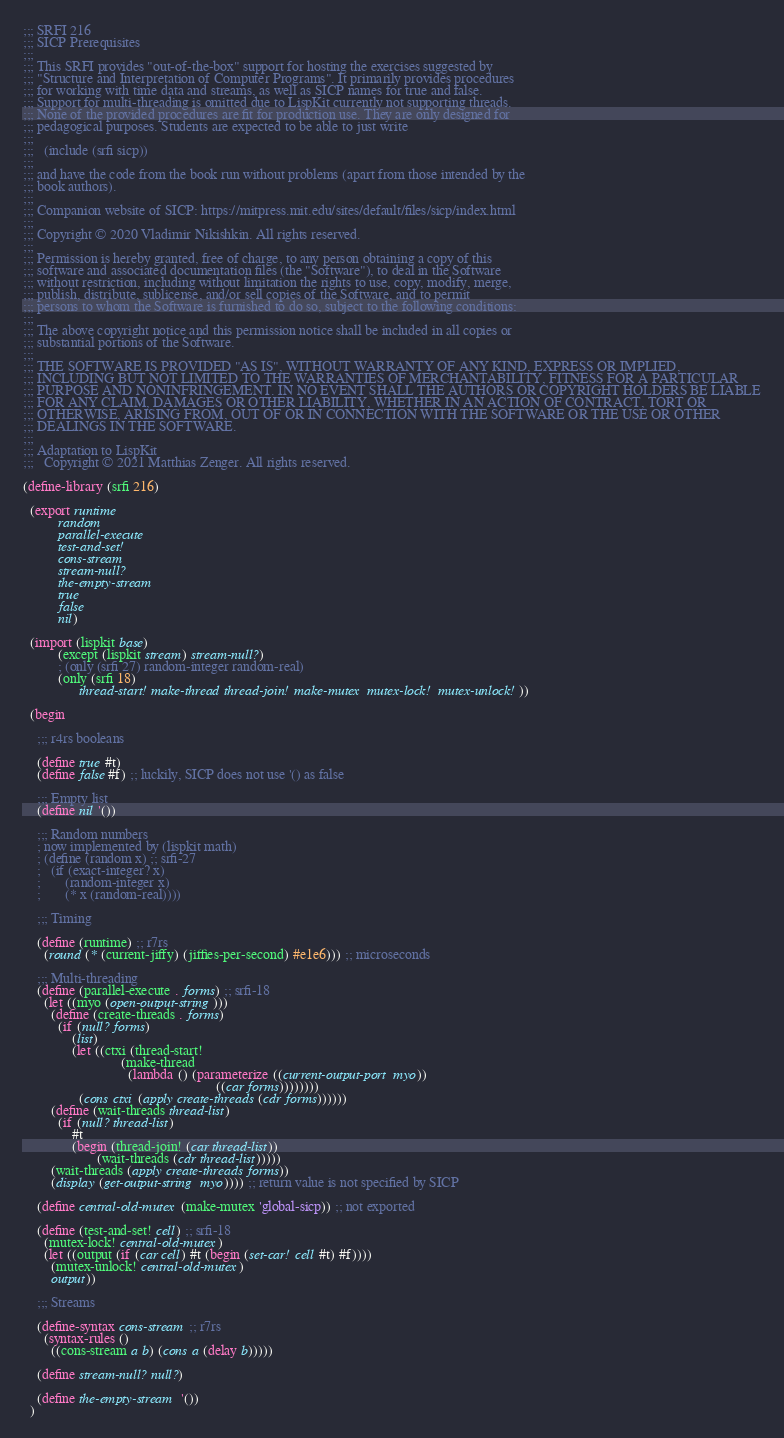Convert code to text. <code><loc_0><loc_0><loc_500><loc_500><_Scheme_>;;; SRFI 216
;;; SICP Prerequisites
;;;
;;; This SRFI provides "out-of-the-box" support for hosting the exercises suggested by
;;; "Structure and Interpretation of Computer Programs". It primarily provides procedures
;;; for working with time data and streams, as well as SICP names for true and false.
;;; Support for multi-threading is omitted due to LispKit currently not supporting threads.
;;; None of the provided procedures are fit for production use. They are only designed for
;;; pedagogical purposes. Students are expected to be able to just write
;;;
;;;   (include (srfi sicp))
;;;
;;; and have the code from the book run without problems (apart from those intended by the
;;; book authors).
;;;
;;; Companion website of SICP: https://mitpress.mit.edu/sites/default/files/sicp/index.html
;;;
;;; Copyright © 2020 Vladimir Nikishkin. All rights reserved.
;;;
;;; Permission is hereby granted, free of charge, to any person obtaining a copy of this
;;; software and associated documentation files (the "Software"), to deal in the Software
;;; without restriction, including without limitation the rights to use, copy, modify, merge,
;;; publish, distribute, sublicense, and/or sell copies of the Software, and to permit
;;; persons to whom the Software is furnished to do so, subject to the following conditions:
;;;
;;; The above copyright notice and this permission notice shall be included in all copies or
;;; substantial portions of the Software.
;;;
;;; THE SOFTWARE IS PROVIDED "AS IS", WITHOUT WARRANTY OF ANY KIND, EXPRESS OR IMPLIED,
;;; INCLUDING BUT NOT LIMITED TO THE WARRANTIES OF MERCHANTABILITY, FITNESS FOR A PARTICULAR
;;; PURPOSE AND NONINFRINGEMENT. IN NO EVENT SHALL THE AUTHORS OR COPYRIGHT HOLDERS BE LIABLE
;;; FOR ANY CLAIM, DAMAGES OR OTHER LIABILITY, WHETHER IN AN ACTION OF CONTRACT, TORT OR
;;; OTHERWISE, ARISING FROM, OUT OF OR IN CONNECTION WITH THE SOFTWARE OR THE USE OR OTHER
;;; DEALINGS IN THE SOFTWARE.
;;;
;;; Adaptation to LispKit
;;;   Copyright © 2021 Matthias Zenger. All rights reserved.

(define-library (srfi 216)

  (export runtime
          random
          parallel-execute
          test-and-set!
          cons-stream
          stream-null?
          the-empty-stream
          true
          false
          nil)

  (import (lispkit base)
          (except (lispkit stream) stream-null?)
          ; (only (srfi 27) random-integer random-real)
          (only (srfi 18)
                thread-start! make-thread thread-join! make-mutex mutex-lock! mutex-unlock!))

  (begin

    ;;; r4rs booleans

    (define true #t)
    (define false #f) ;; luckily, SICP does not use '() as false

    ;;; Empty list
    (define nil '())

    ;;; Random numbers
    ; now implemented by (lispkit math)
    ; (define (random x) ;; srfi-27
    ;   (if (exact-integer? x)
    ;       (random-integer x)
    ;       (* x (random-real))))

    ;;; Timing

    (define (runtime) ;; r7rs
      (round (* (current-jiffy) (jiffies-per-second) #e1e6))) ;; microseconds

    ;;; Multi-threading
    (define (parallel-execute . forms) ;; srfi-18
      (let ((myo (open-output-string)))
        (define (create-threads . forms)
          (if (null? forms)
              (list)
              (let ((ctxi (thread-start!
                            (make-thread
                              (lambda () (parameterize ((current-output-port myo))
                                                       ((car forms))))))))
                (cons ctxi (apply create-threads (cdr forms))))))
        (define (wait-threads thread-list)
          (if (null? thread-list)
              #t
              (begin (thread-join! (car thread-list))
                     (wait-threads (cdr thread-list)))))
        (wait-threads (apply create-threads forms))
        (display (get-output-string myo)))) ;; return value is not specified by SICP
   
    (define central-old-mutex (make-mutex 'global-sicp)) ;; not exported
   
    (define (test-and-set! cell) ;; srfi-18
      (mutex-lock! central-old-mutex)
      (let ((output (if (car cell) #t (begin (set-car! cell #t) #f))))
        (mutex-unlock! central-old-mutex)
        output))
    
    ;;; Streams

    (define-syntax cons-stream ;; r7rs
      (syntax-rules ()
        ((cons-stream a b) (cons a (delay b)))))

    (define stream-null? null?)

    (define the-empty-stream '())
  )</code> 